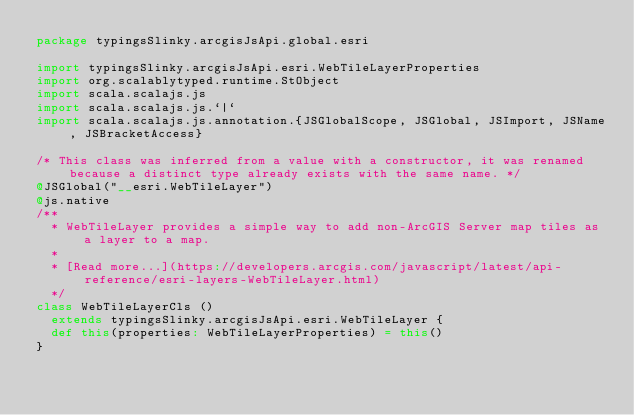<code> <loc_0><loc_0><loc_500><loc_500><_Scala_>package typingsSlinky.arcgisJsApi.global.esri

import typingsSlinky.arcgisJsApi.esri.WebTileLayerProperties
import org.scalablytyped.runtime.StObject
import scala.scalajs.js
import scala.scalajs.js.`|`
import scala.scalajs.js.annotation.{JSGlobalScope, JSGlobal, JSImport, JSName, JSBracketAccess}

/* This class was inferred from a value with a constructor, it was renamed because a distinct type already exists with the same name. */
@JSGlobal("__esri.WebTileLayer")
@js.native
/**
  * WebTileLayer provides a simple way to add non-ArcGIS Server map tiles as a layer to a map.
  *
  * [Read more...](https://developers.arcgis.com/javascript/latest/api-reference/esri-layers-WebTileLayer.html)
  */
class WebTileLayerCls ()
  extends typingsSlinky.arcgisJsApi.esri.WebTileLayer {
  def this(properties: WebTileLayerProperties) = this()
}
</code> 